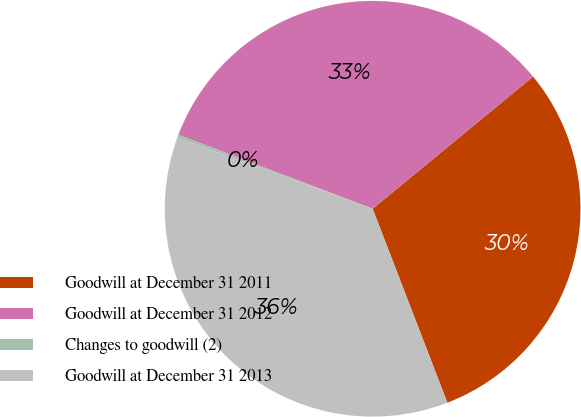<chart> <loc_0><loc_0><loc_500><loc_500><pie_chart><fcel>Goodwill at December 31 2011<fcel>Goodwill at December 31 2012<fcel>Changes to goodwill (2)<fcel>Goodwill at December 31 2013<nl><fcel>30.11%<fcel>33.25%<fcel>0.24%<fcel>36.4%<nl></chart> 